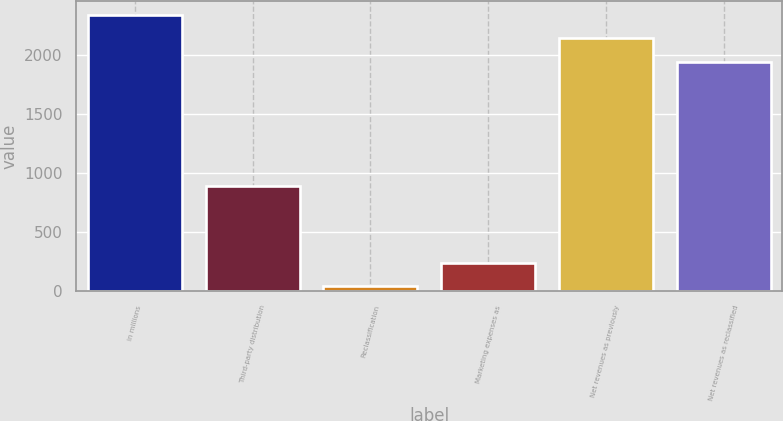Convert chart. <chart><loc_0><loc_0><loc_500><loc_500><bar_chart><fcel>in millions<fcel>Third-party distribution<fcel>Reclassification<fcel>Marketing expenses as<fcel>Net revenues as previously<fcel>Net revenues as reclassified<nl><fcel>2334.08<fcel>889.94<fcel>43.6<fcel>240.14<fcel>2137.54<fcel>1941<nl></chart> 